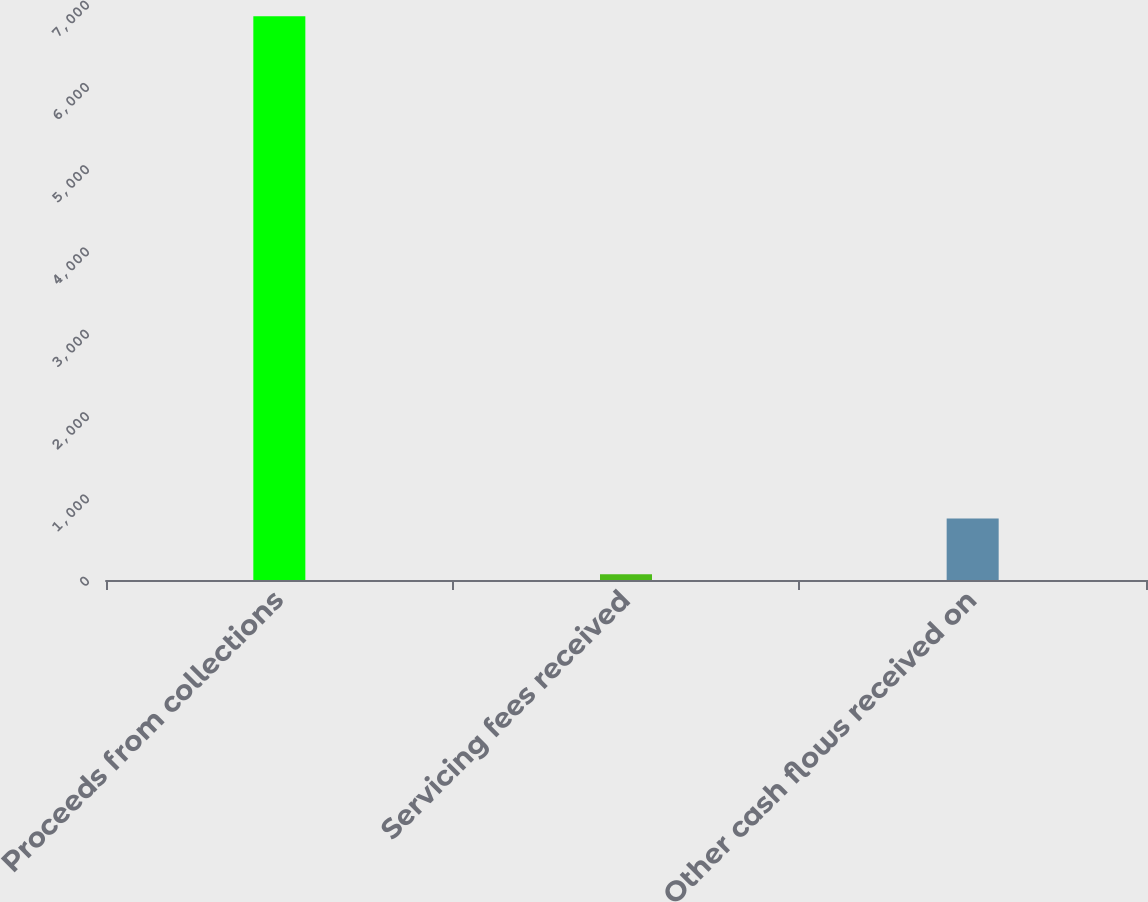<chart> <loc_0><loc_0><loc_500><loc_500><bar_chart><fcel>Proceeds from collections<fcel>Servicing fees received<fcel>Other cash flows received on<nl><fcel>6851.5<fcel>68.5<fcel>746.8<nl></chart> 